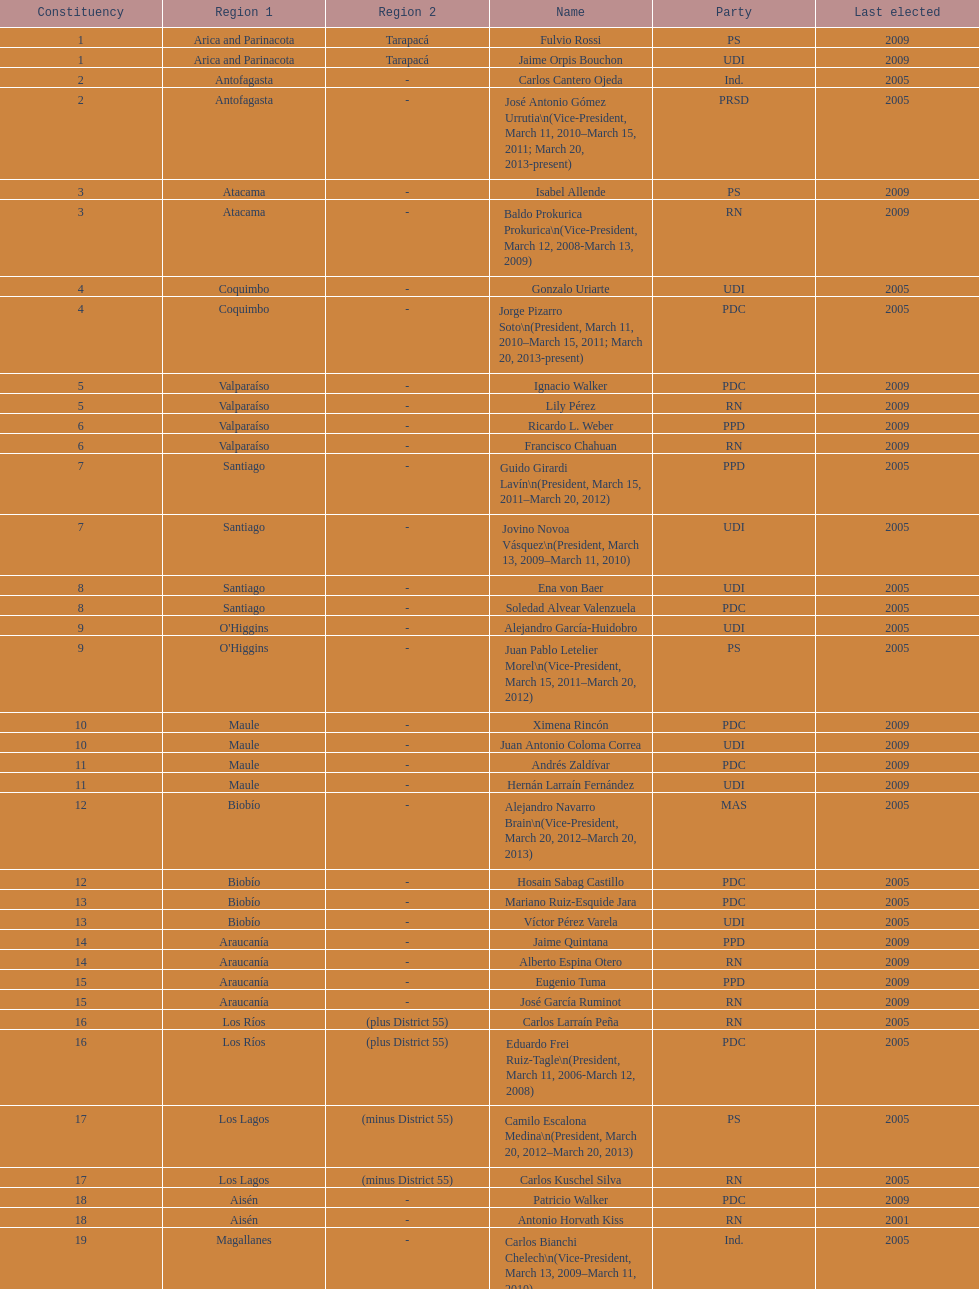What is the first name on the table? Fulvio Rossi. 